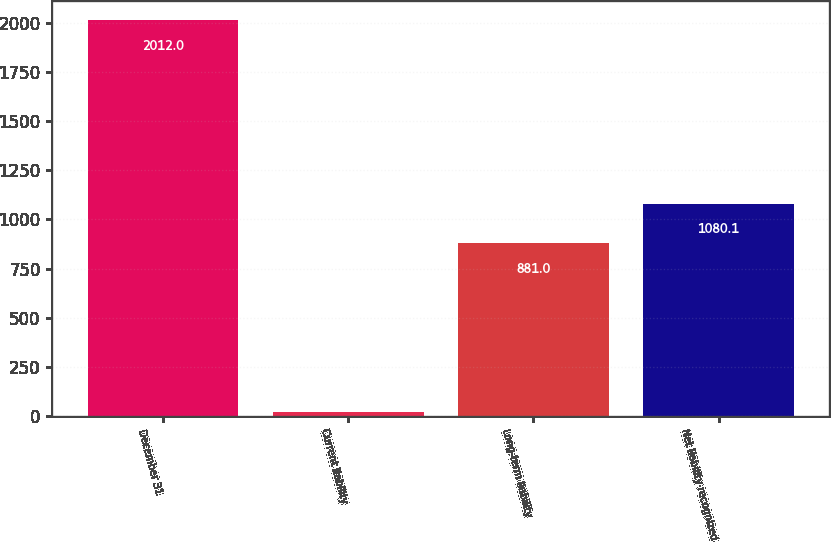<chart> <loc_0><loc_0><loc_500><loc_500><bar_chart><fcel>December 31<fcel>Current liability<fcel>Long-term liability<fcel>Net liability recognized<nl><fcel>2012<fcel>21<fcel>881<fcel>1080.1<nl></chart> 